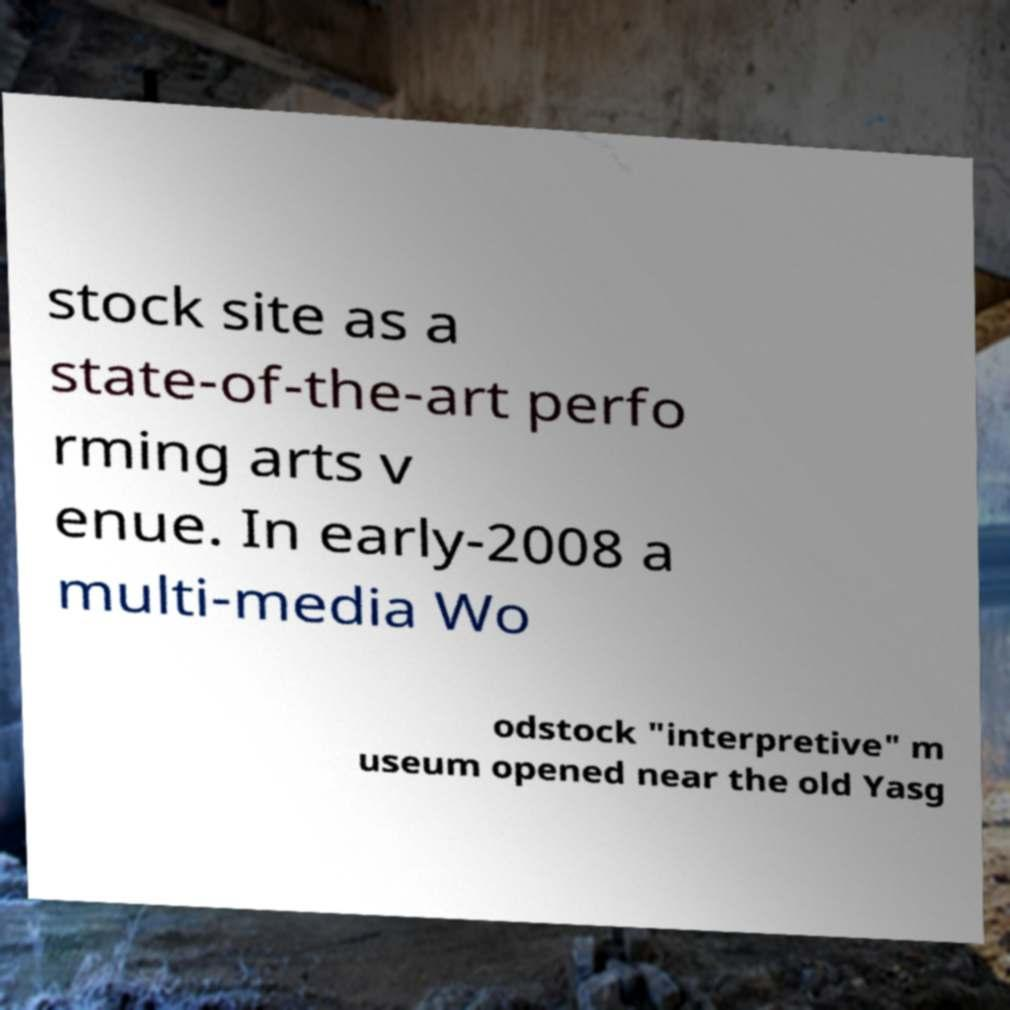Can you read and provide the text displayed in the image?This photo seems to have some interesting text. Can you extract and type it out for me? stock site as a state-of-the-art perfo rming arts v enue. In early-2008 a multi-media Wo odstock "interpretive" m useum opened near the old Yasg 